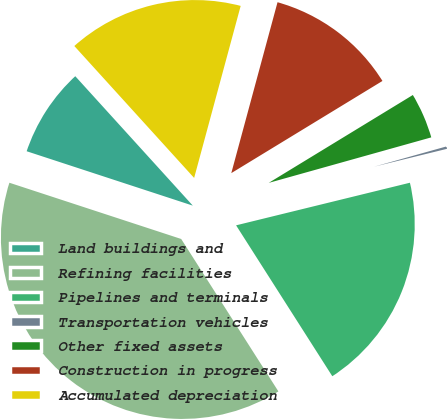Convert chart. <chart><loc_0><loc_0><loc_500><loc_500><pie_chart><fcel>Land buildings and<fcel>Refining facilities<fcel>Pipelines and terminals<fcel>Transportation vehicles<fcel>Other fixed assets<fcel>Construction in progress<fcel>Accumulated depreciation<nl><fcel>8.23%<fcel>39.07%<fcel>19.79%<fcel>0.52%<fcel>4.37%<fcel>12.08%<fcel>15.94%<nl></chart> 